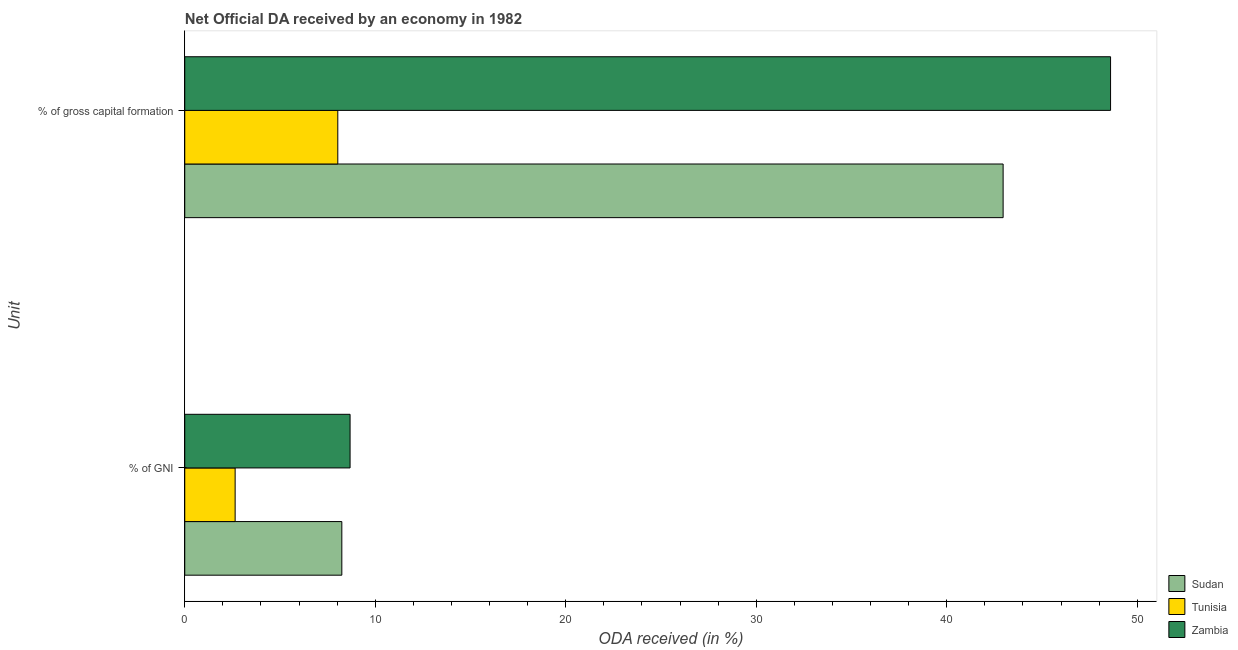Are the number of bars per tick equal to the number of legend labels?
Give a very brief answer. Yes. Are the number of bars on each tick of the Y-axis equal?
Offer a terse response. Yes. What is the label of the 1st group of bars from the top?
Provide a short and direct response. % of gross capital formation. What is the oda received as percentage of gross capital formation in Sudan?
Offer a terse response. 42.96. Across all countries, what is the maximum oda received as percentage of gni?
Give a very brief answer. 8.68. Across all countries, what is the minimum oda received as percentage of gross capital formation?
Provide a short and direct response. 8.03. In which country was the oda received as percentage of gni maximum?
Give a very brief answer. Zambia. In which country was the oda received as percentage of gni minimum?
Offer a terse response. Tunisia. What is the total oda received as percentage of gni in the graph?
Give a very brief answer. 19.57. What is the difference between the oda received as percentage of gross capital formation in Tunisia and that in Zambia?
Your response must be concise. -40.57. What is the difference between the oda received as percentage of gni in Tunisia and the oda received as percentage of gross capital formation in Zambia?
Your response must be concise. -45.96. What is the average oda received as percentage of gni per country?
Your response must be concise. 6.52. What is the difference between the oda received as percentage of gross capital formation and oda received as percentage of gni in Sudan?
Make the answer very short. 34.71. What is the ratio of the oda received as percentage of gross capital formation in Sudan to that in Tunisia?
Keep it short and to the point. 5.35. Is the oda received as percentage of gni in Zambia less than that in Sudan?
Provide a succinct answer. No. What does the 2nd bar from the top in % of gross capital formation represents?
Your answer should be compact. Tunisia. What does the 1st bar from the bottom in % of gross capital formation represents?
Provide a short and direct response. Sudan. Are the values on the major ticks of X-axis written in scientific E-notation?
Your answer should be compact. No. Does the graph contain any zero values?
Give a very brief answer. No. Does the graph contain grids?
Keep it short and to the point. No. How are the legend labels stacked?
Keep it short and to the point. Vertical. What is the title of the graph?
Your answer should be compact. Net Official DA received by an economy in 1982. What is the label or title of the X-axis?
Offer a very short reply. ODA received (in %). What is the label or title of the Y-axis?
Ensure brevity in your answer.  Unit. What is the ODA received (in %) of Sudan in % of GNI?
Your response must be concise. 8.25. What is the ODA received (in %) in Tunisia in % of GNI?
Offer a very short reply. 2.64. What is the ODA received (in %) of Zambia in % of GNI?
Offer a terse response. 8.68. What is the ODA received (in %) in Sudan in % of gross capital formation?
Your response must be concise. 42.96. What is the ODA received (in %) of Tunisia in % of gross capital formation?
Offer a very short reply. 8.03. What is the ODA received (in %) in Zambia in % of gross capital formation?
Provide a succinct answer. 48.6. Across all Unit, what is the maximum ODA received (in %) in Sudan?
Offer a very short reply. 42.96. Across all Unit, what is the maximum ODA received (in %) of Tunisia?
Provide a short and direct response. 8.03. Across all Unit, what is the maximum ODA received (in %) of Zambia?
Ensure brevity in your answer.  48.6. Across all Unit, what is the minimum ODA received (in %) of Sudan?
Your answer should be very brief. 8.25. Across all Unit, what is the minimum ODA received (in %) in Tunisia?
Offer a terse response. 2.64. Across all Unit, what is the minimum ODA received (in %) of Zambia?
Offer a terse response. 8.68. What is the total ODA received (in %) in Sudan in the graph?
Offer a terse response. 51.21. What is the total ODA received (in %) in Tunisia in the graph?
Give a very brief answer. 10.68. What is the total ODA received (in %) of Zambia in the graph?
Your answer should be compact. 57.28. What is the difference between the ODA received (in %) of Sudan in % of GNI and that in % of gross capital formation?
Offer a very short reply. -34.71. What is the difference between the ODA received (in %) of Tunisia in % of GNI and that in % of gross capital formation?
Your response must be concise. -5.39. What is the difference between the ODA received (in %) of Zambia in % of GNI and that in % of gross capital formation?
Keep it short and to the point. -39.92. What is the difference between the ODA received (in %) of Sudan in % of GNI and the ODA received (in %) of Tunisia in % of gross capital formation?
Offer a very short reply. 0.21. What is the difference between the ODA received (in %) in Sudan in % of GNI and the ODA received (in %) in Zambia in % of gross capital formation?
Provide a short and direct response. -40.35. What is the difference between the ODA received (in %) in Tunisia in % of GNI and the ODA received (in %) in Zambia in % of gross capital formation?
Your answer should be compact. -45.96. What is the average ODA received (in %) of Sudan per Unit?
Provide a short and direct response. 25.6. What is the average ODA received (in %) in Tunisia per Unit?
Give a very brief answer. 5.34. What is the average ODA received (in %) of Zambia per Unit?
Your answer should be compact. 28.64. What is the difference between the ODA received (in %) of Sudan and ODA received (in %) of Tunisia in % of GNI?
Your answer should be very brief. 5.6. What is the difference between the ODA received (in %) in Sudan and ODA received (in %) in Zambia in % of GNI?
Offer a very short reply. -0.43. What is the difference between the ODA received (in %) of Tunisia and ODA received (in %) of Zambia in % of GNI?
Keep it short and to the point. -6.03. What is the difference between the ODA received (in %) of Sudan and ODA received (in %) of Tunisia in % of gross capital formation?
Provide a short and direct response. 34.93. What is the difference between the ODA received (in %) in Sudan and ODA received (in %) in Zambia in % of gross capital formation?
Your answer should be very brief. -5.64. What is the difference between the ODA received (in %) of Tunisia and ODA received (in %) of Zambia in % of gross capital formation?
Provide a succinct answer. -40.57. What is the ratio of the ODA received (in %) of Sudan in % of GNI to that in % of gross capital formation?
Ensure brevity in your answer.  0.19. What is the ratio of the ODA received (in %) of Tunisia in % of GNI to that in % of gross capital formation?
Provide a short and direct response. 0.33. What is the ratio of the ODA received (in %) of Zambia in % of GNI to that in % of gross capital formation?
Keep it short and to the point. 0.18. What is the difference between the highest and the second highest ODA received (in %) of Sudan?
Give a very brief answer. 34.71. What is the difference between the highest and the second highest ODA received (in %) in Tunisia?
Your answer should be compact. 5.39. What is the difference between the highest and the second highest ODA received (in %) of Zambia?
Your answer should be very brief. 39.92. What is the difference between the highest and the lowest ODA received (in %) in Sudan?
Offer a terse response. 34.71. What is the difference between the highest and the lowest ODA received (in %) of Tunisia?
Your response must be concise. 5.39. What is the difference between the highest and the lowest ODA received (in %) in Zambia?
Offer a terse response. 39.92. 